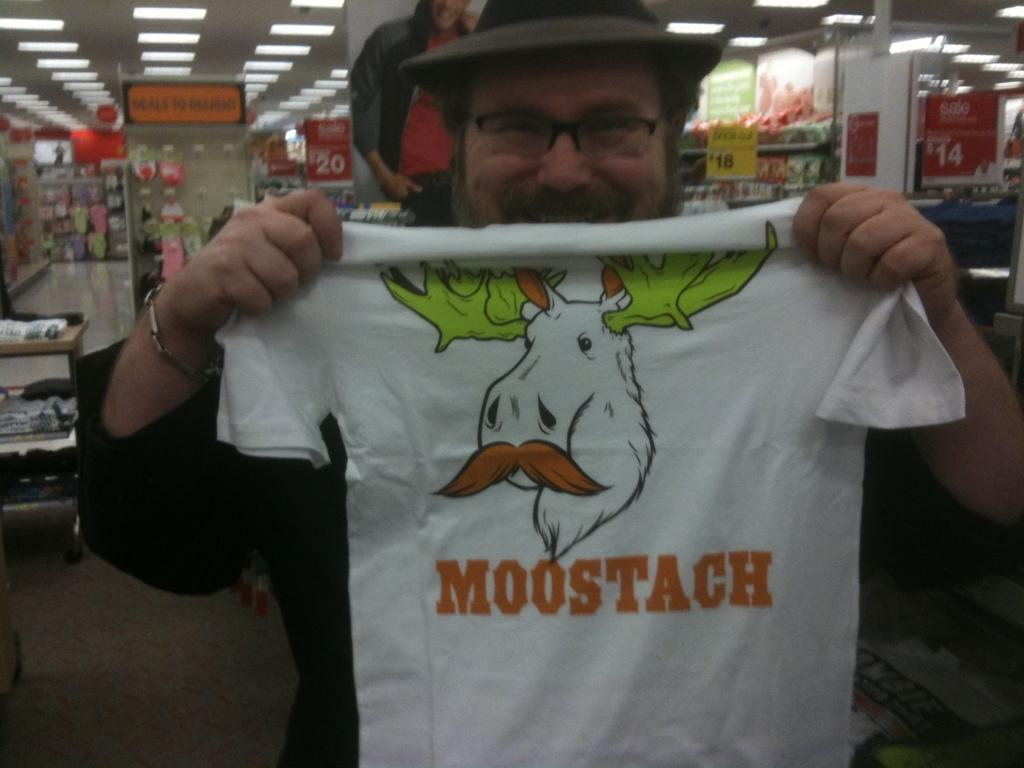What type of location is depicted in the image? The image shows an inside view of a store. Can you describe the person in the image? There is a man in the image, and he is holding a T-shirt. What type of advertisements can be seen in the image? There are hoardings visible in the image. What is the lighting like in the store? There are lights in the image. What other items can be seen in the store besides the man and the T-shirt? There are other unspecified items in the image. What type of vessel is being used to transport the star in the image? There is no vessel or star present in the image; it shows an inside view of a store with a man holding a T-shirt. 